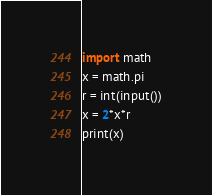Convert code to text. <code><loc_0><loc_0><loc_500><loc_500><_Python_>import math
x = math.pi
r = int(input())
x = 2*x*r
print(x)</code> 